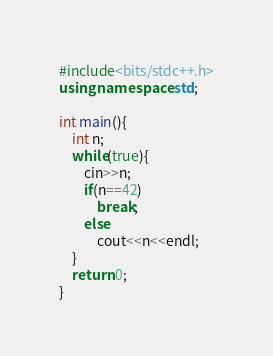Convert code to text. <code><loc_0><loc_0><loc_500><loc_500><_C++_>#include<bits/stdc++.h>
using namespace std;

int main(){
    int n;
    while(true){
        cin>>n;
        if(n==42)
            break;
        else
            cout<<n<<endl;
    }
    return 0;
}</code> 